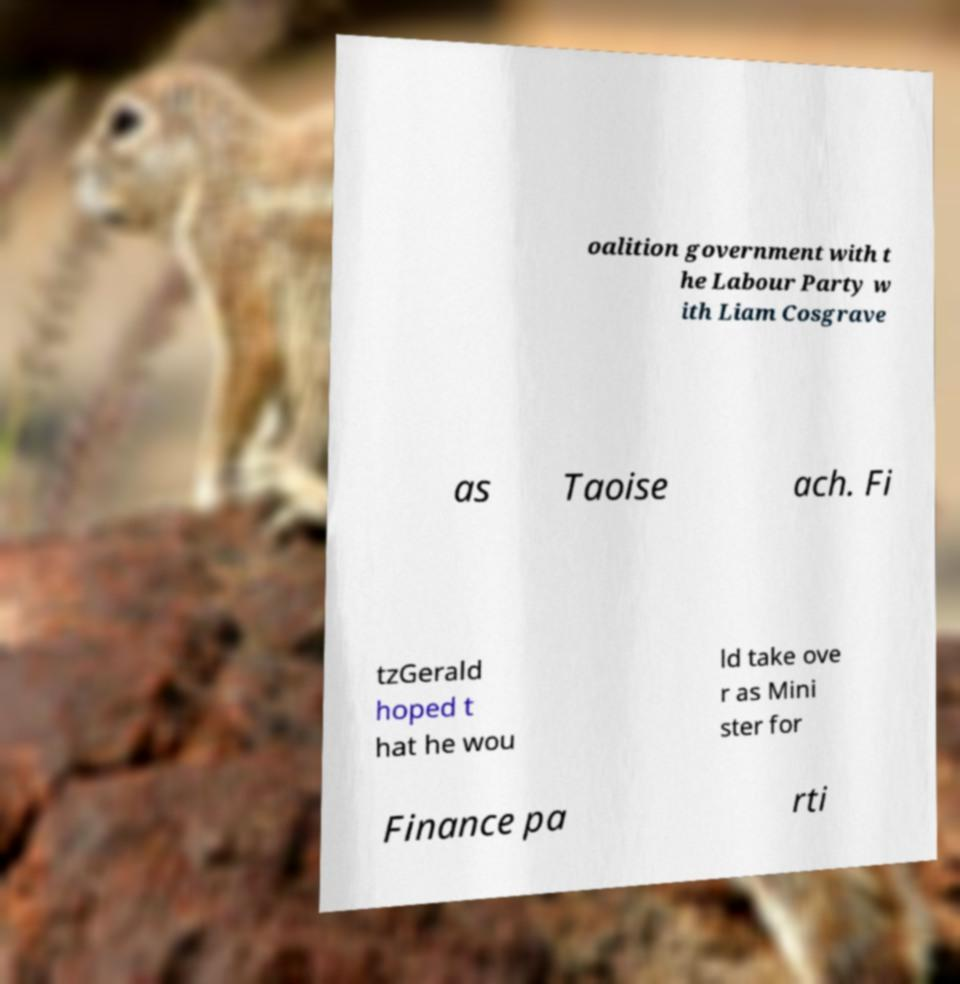Please read and relay the text visible in this image. What does it say? oalition government with t he Labour Party w ith Liam Cosgrave as Taoise ach. Fi tzGerald hoped t hat he wou ld take ove r as Mini ster for Finance pa rti 